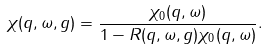Convert formula to latex. <formula><loc_0><loc_0><loc_500><loc_500>\chi ( q , \omega , g ) = \frac { \chi _ { 0 } ( q , \omega ) } { 1 - R ( q , \omega , g ) \chi _ { 0 } ( q , \omega ) } .</formula> 